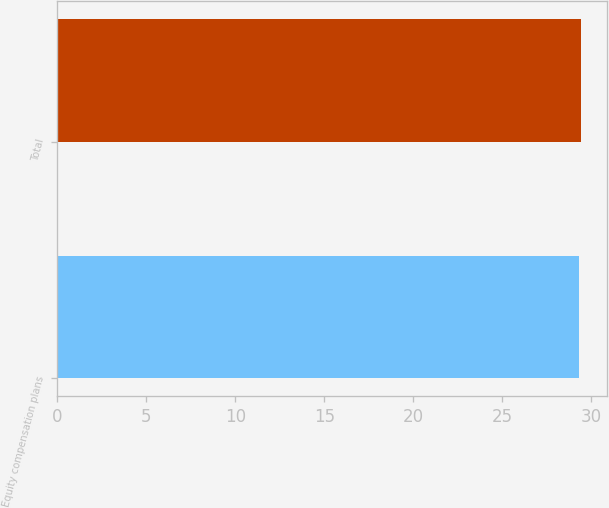<chart> <loc_0><loc_0><loc_500><loc_500><bar_chart><fcel>Equity compensation plans<fcel>Total<nl><fcel>29.34<fcel>29.44<nl></chart> 